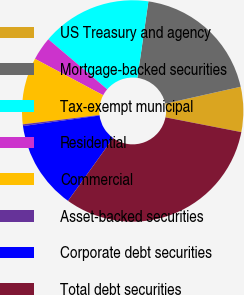<chart> <loc_0><loc_0><loc_500><loc_500><pie_chart><fcel>US Treasury and agency<fcel>Mortgage-backed securities<fcel>Tax-exempt municipal<fcel>Residential<fcel>Commercial<fcel>Asset-backed securities<fcel>Corporate debt securities<fcel>Total debt securities<nl><fcel>6.57%<fcel>19.22%<fcel>16.06%<fcel>3.41%<fcel>9.73%<fcel>0.25%<fcel>12.9%<fcel>31.86%<nl></chart> 